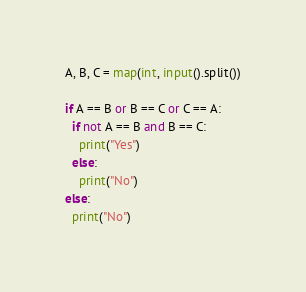<code> <loc_0><loc_0><loc_500><loc_500><_Python_>A, B, C = map(int, input().split())

if A == B or B == C or C == A:
  if not A == B and B == C:
    print("Yes")
  else:
    print("No")
else:
  print("No")</code> 